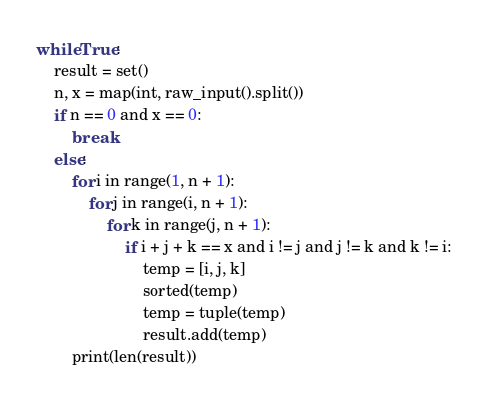Convert code to text. <code><loc_0><loc_0><loc_500><loc_500><_Python_>while True:
    result = set()
    n, x = map(int, raw_input().split())
    if n == 0 and x == 0:
        break
    else:
        for i in range(1, n + 1):
            for j in range(i, n + 1):
                for k in range(j, n + 1):
                    if i + j + k == x and i != j and j != k and k != i:
                        temp = [i, j, k]
                        sorted(temp)
                        temp = tuple(temp)
                        result.add(temp)
        print(len(result))</code> 